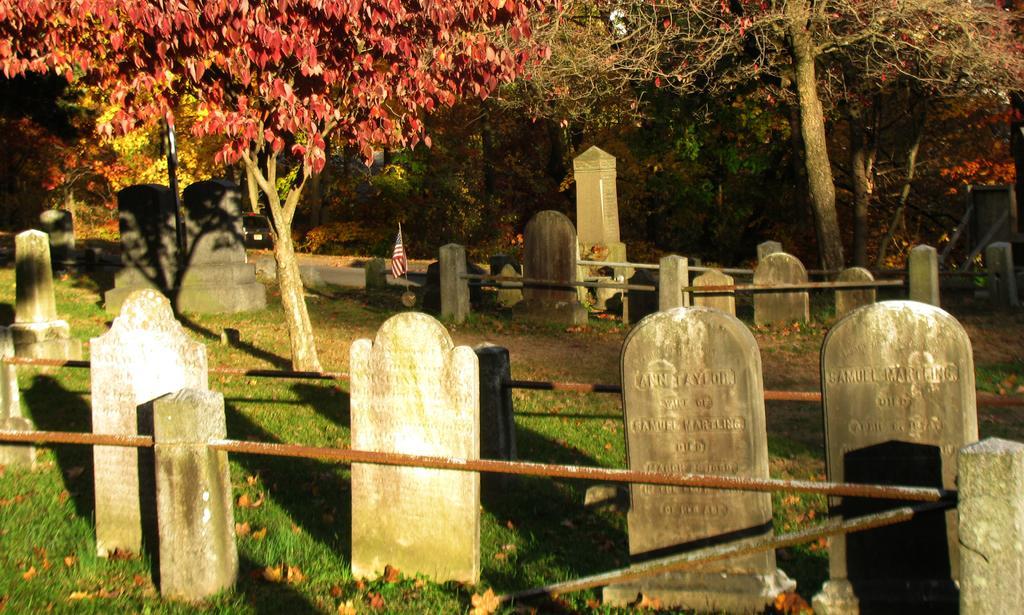Can you describe this image briefly? In this image I can see few cemeteries. Back I can see trees and red color leaves. I can see flag and pole around. 